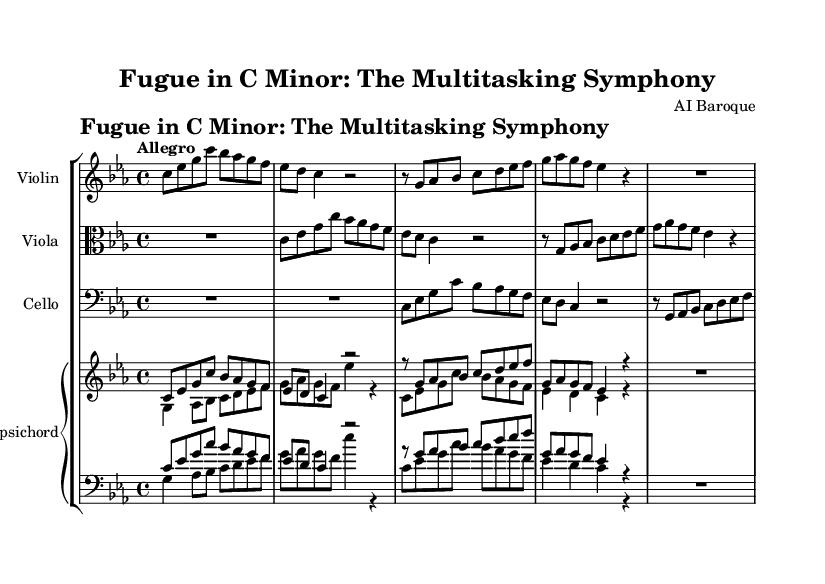what is the key signature of this music? The key signature is indicated at the beginning of the staff. It shows three flat signs, which correspond to the key of C minor.
Answer: C minor what is the time signature of this music? The time signature is shown right after the key signature at the beginning of the score. It displays a "4/4" which means there are four beats in each measure.
Answer: 4/4 what is the tempo marking of this composition? The tempo marking is indicated above the beginning of the music, stating "Allegro." This term suggests a fast and lively tempo.
Answer: Allegro which instruments are featured in this fugue? The instruments are listed at the beginning of each staff. They include Violin, Viola, Cello, and Harpsichord (two staves).
Answer: Violin, Viola, Cello, Harpsichord how many voices are there in the harpsichord section? The harpsichord part is divided into two staves, which represent two distinct voices playing simultaneously. This is common in Baroque music, allowing for polyphonic texture.
Answer: Two what is the structural role of the 'R' notations in the cello part? The 'R' notations in the cello part indicate a rest, where the instrument does not play for the indicated durations. This contributes to the overall flow and textural layering in the fugue, as other instruments continue to play.
Answer: Rest what compositional technique exemplifies multitasking in this fugue? The score shows multiple independent melodies developing simultaneously, particularly in the counterpoint of the four instruments, which is a defining characteristic of Baroque fugues. This simultaneous interaction is essentially a form of parallel processing in music.
Answer: Counterpoint 